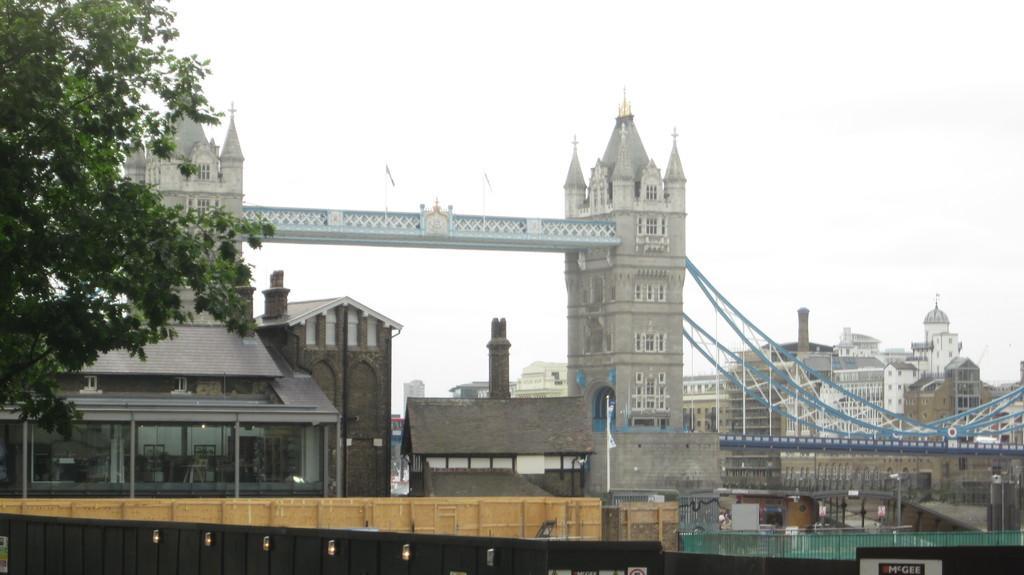Could you give a brief overview of what you see in this image? In this picture I can observe a bridge in the middle of the picture. In front of the bridge I can observe buildings. On the left side I can observe tree. In the background there is sky. 